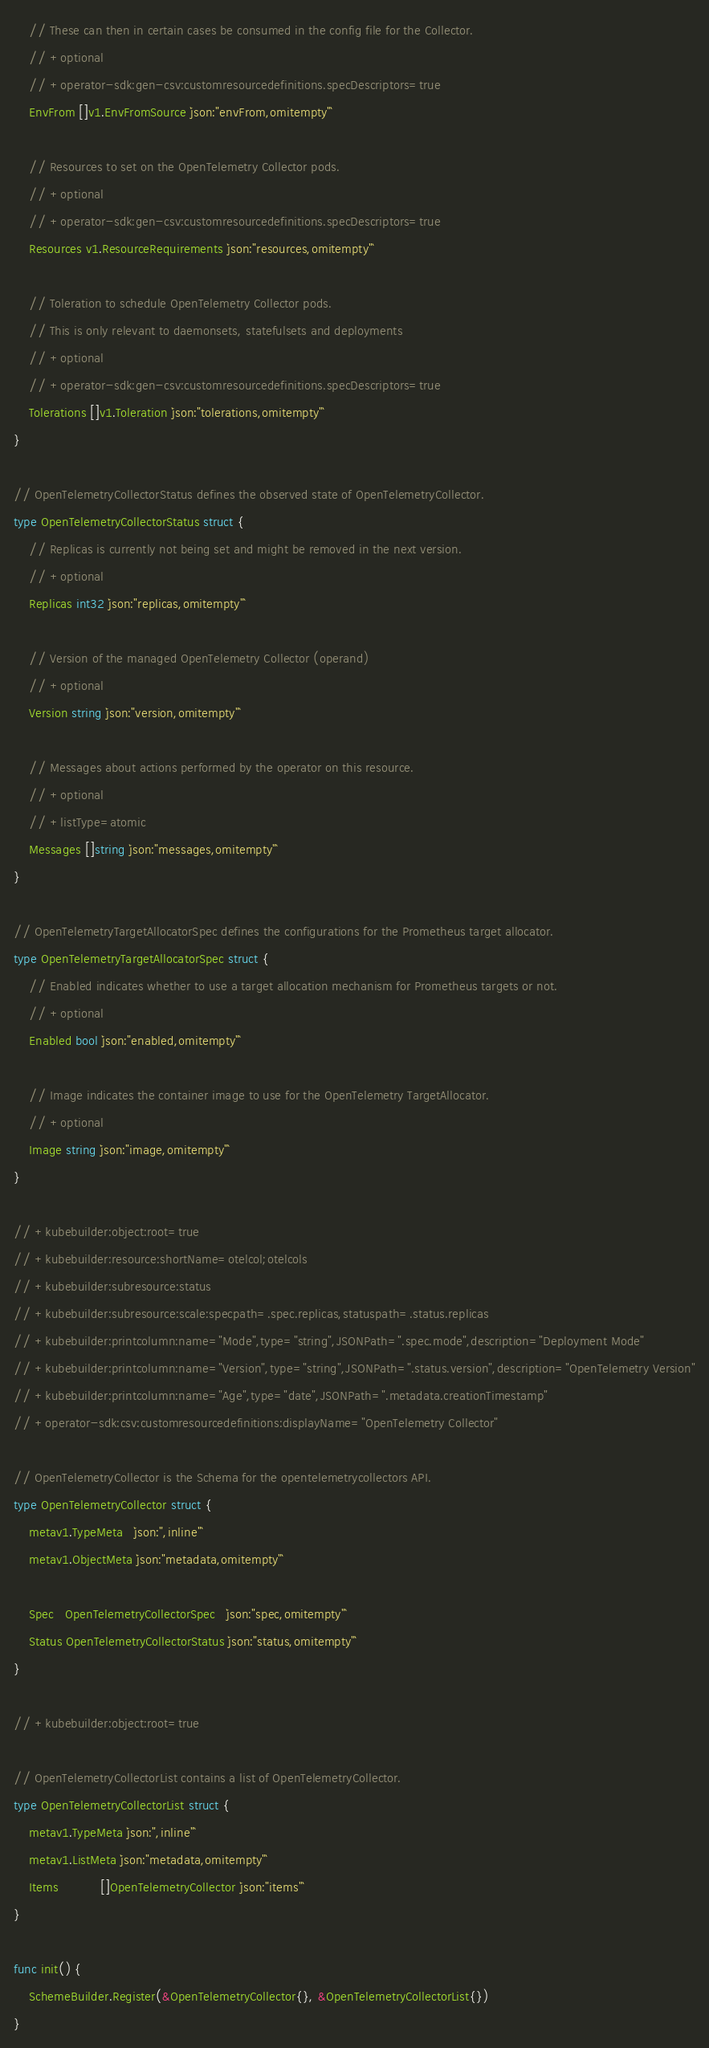<code> <loc_0><loc_0><loc_500><loc_500><_Go_>	// These can then in certain cases be consumed in the config file for the Collector.
	// +optional
	// +operator-sdk:gen-csv:customresourcedefinitions.specDescriptors=true
	EnvFrom []v1.EnvFromSource `json:"envFrom,omitempty"`

	// Resources to set on the OpenTelemetry Collector pods.
	// +optional
	// +operator-sdk:gen-csv:customresourcedefinitions.specDescriptors=true
	Resources v1.ResourceRequirements `json:"resources,omitempty"`

	// Toleration to schedule OpenTelemetry Collector pods.
	// This is only relevant to daemonsets, statefulsets and deployments
	// +optional
	// +operator-sdk:gen-csv:customresourcedefinitions.specDescriptors=true
	Tolerations []v1.Toleration `json:"tolerations,omitempty"`
}

// OpenTelemetryCollectorStatus defines the observed state of OpenTelemetryCollector.
type OpenTelemetryCollectorStatus struct {
	// Replicas is currently not being set and might be removed in the next version.
	// +optional
	Replicas int32 `json:"replicas,omitempty"`

	// Version of the managed OpenTelemetry Collector (operand)
	// +optional
	Version string `json:"version,omitempty"`

	// Messages about actions performed by the operator on this resource.
	// +optional
	// +listType=atomic
	Messages []string `json:"messages,omitempty"`
}

// OpenTelemetryTargetAllocatorSpec defines the configurations for the Prometheus target allocator.
type OpenTelemetryTargetAllocatorSpec struct {
	// Enabled indicates whether to use a target allocation mechanism for Prometheus targets or not.
	// +optional
	Enabled bool `json:"enabled,omitempty"`

	// Image indicates the container image to use for the OpenTelemetry TargetAllocator.
	// +optional
	Image string `json:"image,omitempty"`
}

// +kubebuilder:object:root=true
// +kubebuilder:resource:shortName=otelcol;otelcols
// +kubebuilder:subresource:status
// +kubebuilder:subresource:scale:specpath=.spec.replicas,statuspath=.status.replicas
// +kubebuilder:printcolumn:name="Mode",type="string",JSONPath=".spec.mode",description="Deployment Mode"
// +kubebuilder:printcolumn:name="Version",type="string",JSONPath=".status.version",description="OpenTelemetry Version"
// +kubebuilder:printcolumn:name="Age",type="date",JSONPath=".metadata.creationTimestamp"
// +operator-sdk:csv:customresourcedefinitions:displayName="OpenTelemetry Collector"

// OpenTelemetryCollector is the Schema for the opentelemetrycollectors API.
type OpenTelemetryCollector struct {
	metav1.TypeMeta   `json:",inline"`
	metav1.ObjectMeta `json:"metadata,omitempty"`

	Spec   OpenTelemetryCollectorSpec   `json:"spec,omitempty"`
	Status OpenTelemetryCollectorStatus `json:"status,omitempty"`
}

// +kubebuilder:object:root=true

// OpenTelemetryCollectorList contains a list of OpenTelemetryCollector.
type OpenTelemetryCollectorList struct {
	metav1.TypeMeta `json:",inline"`
	metav1.ListMeta `json:"metadata,omitempty"`
	Items           []OpenTelemetryCollector `json:"items"`
}

func init() {
	SchemeBuilder.Register(&OpenTelemetryCollector{}, &OpenTelemetryCollectorList{})
}
</code> 